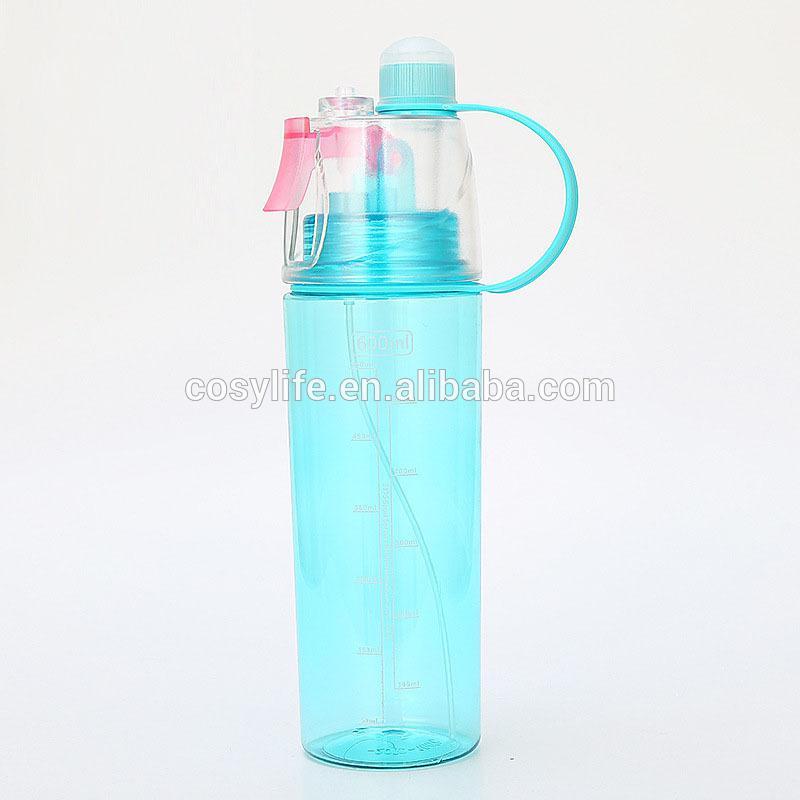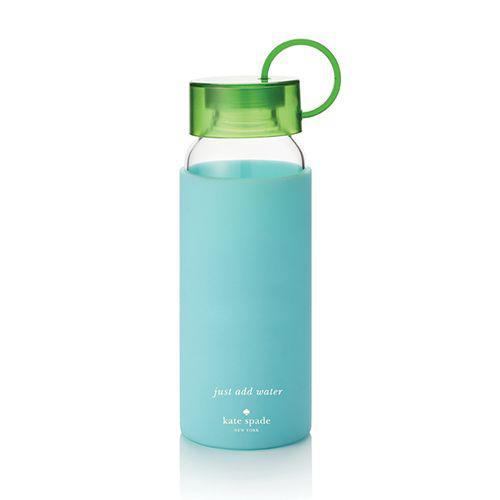The first image is the image on the left, the second image is the image on the right. Examine the images to the left and right. Is the description "The left and right image contains the same number of water bottles with one being green and see through." accurate? Answer yes or no. No. 